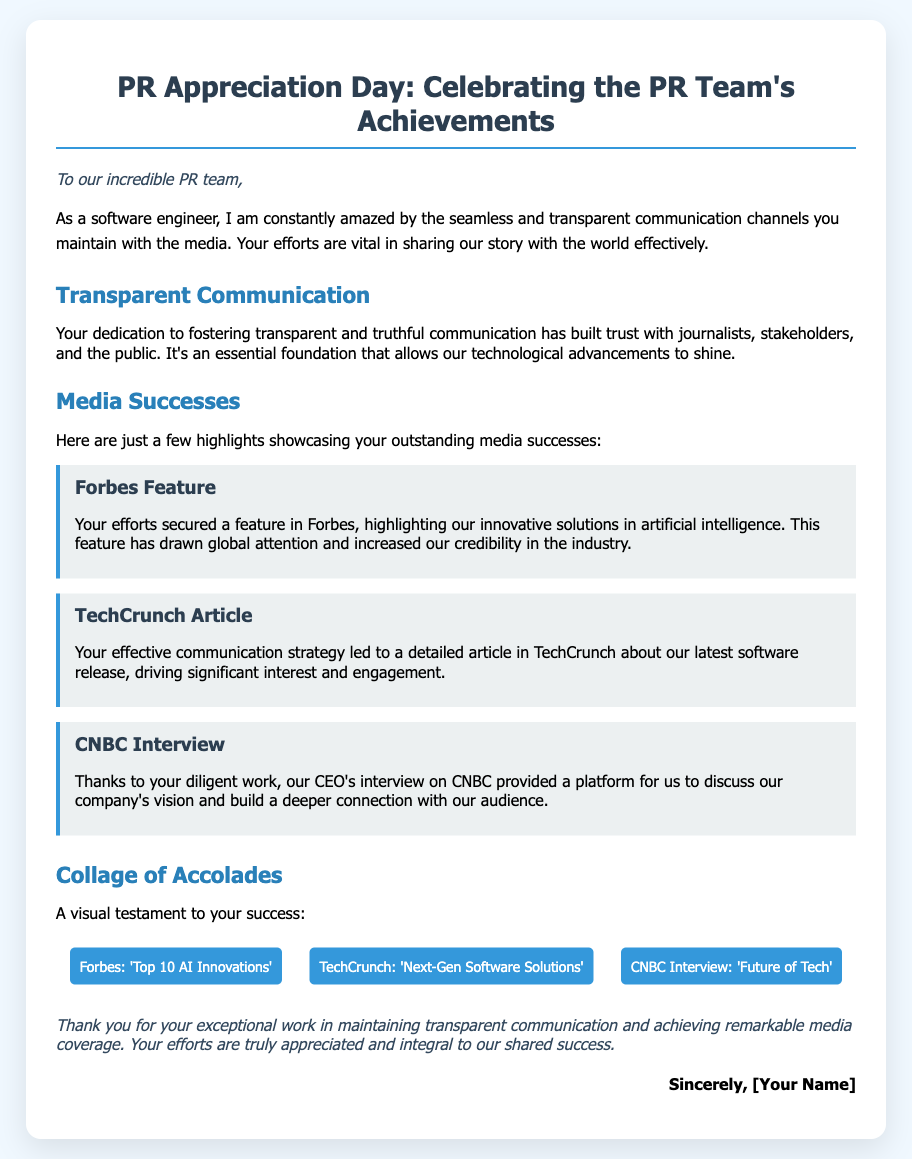What is the title of the document? The title of the document is indicated in the <title> tag, which is "PR Appreciation Day".
Answer: PR Appreciation Day Who is the greeting card addressed to? The greeting card is addressed to the "incredible PR team," as stated in the greeting section of the document.
Answer: incredible PR team What is highlighted in the "Media Successes" section? The "Media Successes" section highlights three key achievements related to media features, specifically a feature in Forbes, an article in TechCrunch, and a CNBC interview.
Answer: Forbes Feature, TechCrunch Article, CNBC Interview Which media outlet featured an article about "Next-Gen Software Solutions"? The document specifically mentions TechCrunch as the media outlet that published an article about "Next-Gen Software Solutions."
Answer: TechCrunch What color is used for the card background? The background color of the card is specified as a light color in the CSS styling, which is "white".
Answer: white How many media successes are listed in the document? The document lists three media successes in the "Media Successes" section.
Answer: three What type of communication does the PR team maintain with the media? The document emphasizes that the PR team maintains "transparent communication" with the media.
Answer: transparent communication What is the tone of the closing statement? The closing statement expresses gratitude and appreciation, indicated by phrases like "thank you" and "truly appreciated".
Answer: gratitude and appreciation 